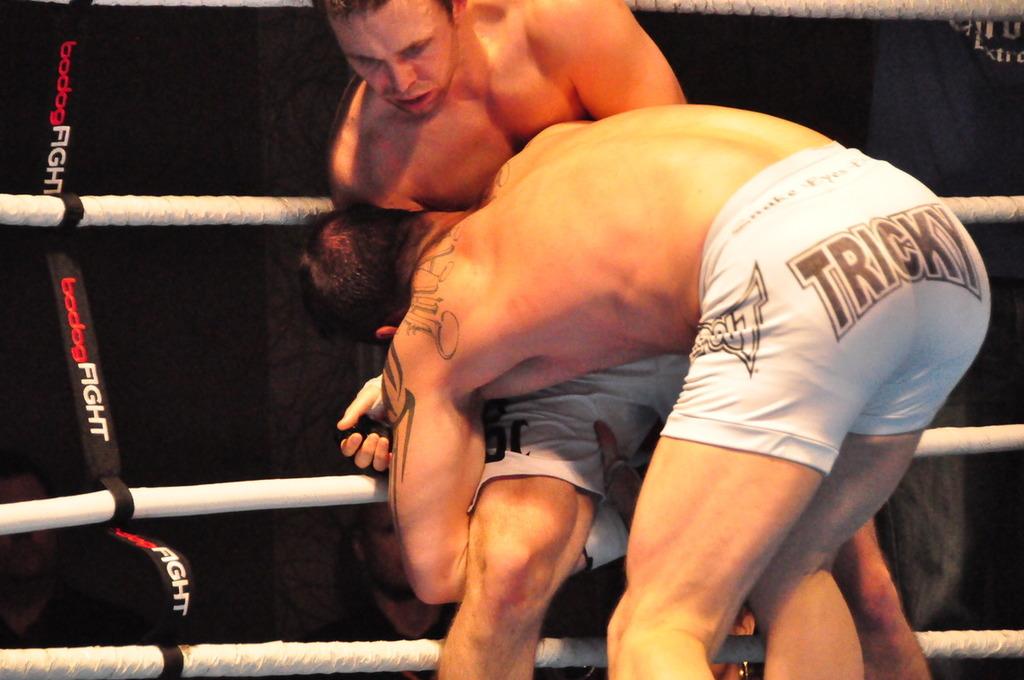What kind of shorts is the wrestler wearing?
Ensure brevity in your answer.  Tricky. What kind of fight?
Keep it short and to the point. Bodog. 